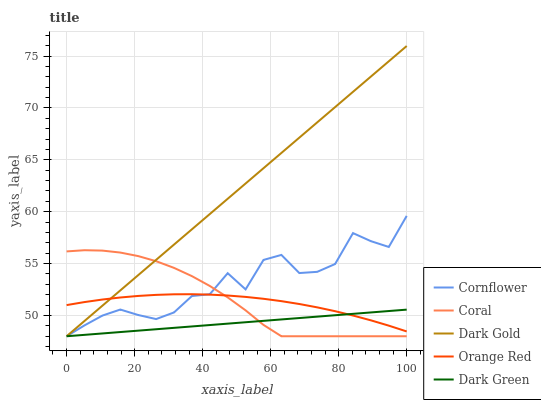Does Dark Green have the minimum area under the curve?
Answer yes or no. Yes. Does Dark Gold have the maximum area under the curve?
Answer yes or no. Yes. Does Coral have the minimum area under the curve?
Answer yes or no. No. Does Coral have the maximum area under the curve?
Answer yes or no. No. Is Dark Green the smoothest?
Answer yes or no. Yes. Is Cornflower the roughest?
Answer yes or no. Yes. Is Coral the smoothest?
Answer yes or no. No. Is Coral the roughest?
Answer yes or no. No. Does Orange Red have the lowest value?
Answer yes or no. No. Does Coral have the highest value?
Answer yes or no. No. 